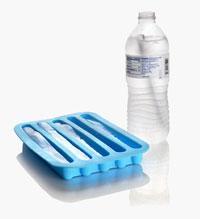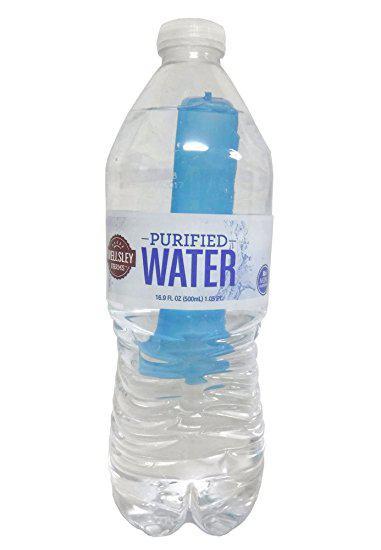The first image is the image on the left, the second image is the image on the right. Given the left and right images, does the statement "An image shows some type of freezing sticks next to a water bottle." hold true? Answer yes or no. Yes. The first image is the image on the left, the second image is the image on the right. Considering the images on both sides, is "One of the bottles is near an ice tray." valid? Answer yes or no. Yes. 